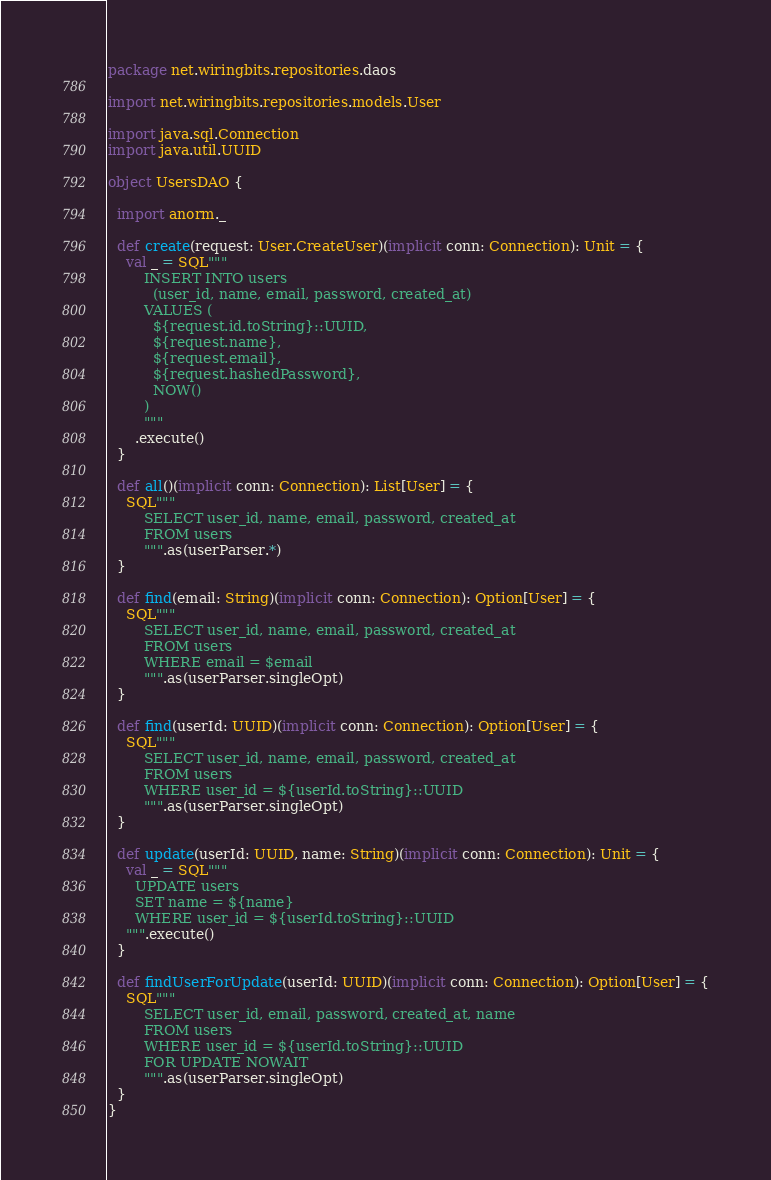<code> <loc_0><loc_0><loc_500><loc_500><_Scala_>package net.wiringbits.repositories.daos

import net.wiringbits.repositories.models.User

import java.sql.Connection
import java.util.UUID

object UsersDAO {

  import anorm._

  def create(request: User.CreateUser)(implicit conn: Connection): Unit = {
    val _ = SQL"""
        INSERT INTO users
          (user_id, name, email, password, created_at)
        VALUES (
          ${request.id.toString}::UUID,
          ${request.name},
          ${request.email},
          ${request.hashedPassword},
          NOW()
        )
        """
      .execute()
  }

  def all()(implicit conn: Connection): List[User] = {
    SQL"""
        SELECT user_id, name, email, password, created_at
        FROM users
        """.as(userParser.*)
  }

  def find(email: String)(implicit conn: Connection): Option[User] = {
    SQL"""
        SELECT user_id, name, email, password, created_at
        FROM users
        WHERE email = $email
        """.as(userParser.singleOpt)
  }

  def find(userId: UUID)(implicit conn: Connection): Option[User] = {
    SQL"""
        SELECT user_id, name, email, password, created_at
        FROM users
        WHERE user_id = ${userId.toString}::UUID
        """.as(userParser.singleOpt)
  }

  def update(userId: UUID, name: String)(implicit conn: Connection): Unit = {
    val _ = SQL"""
      UPDATE users
      SET name = ${name}
      WHERE user_id = ${userId.toString}::UUID
    """.execute()
  }

  def findUserForUpdate(userId: UUID)(implicit conn: Connection): Option[User] = {
    SQL"""
        SELECT user_id, email, password, created_at, name
        FROM users
        WHERE user_id = ${userId.toString}::UUID
        FOR UPDATE NOWAIT
        """.as(userParser.singleOpt)
  }
}
</code> 